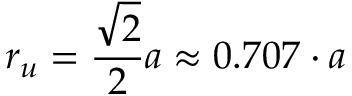Convert formula to latex. <formula><loc_0><loc_0><loc_500><loc_500>r _ { u } = { \frac { \sqrt { 2 } } { 2 } } a \approx 0 . 7 0 7 \cdot a</formula> 